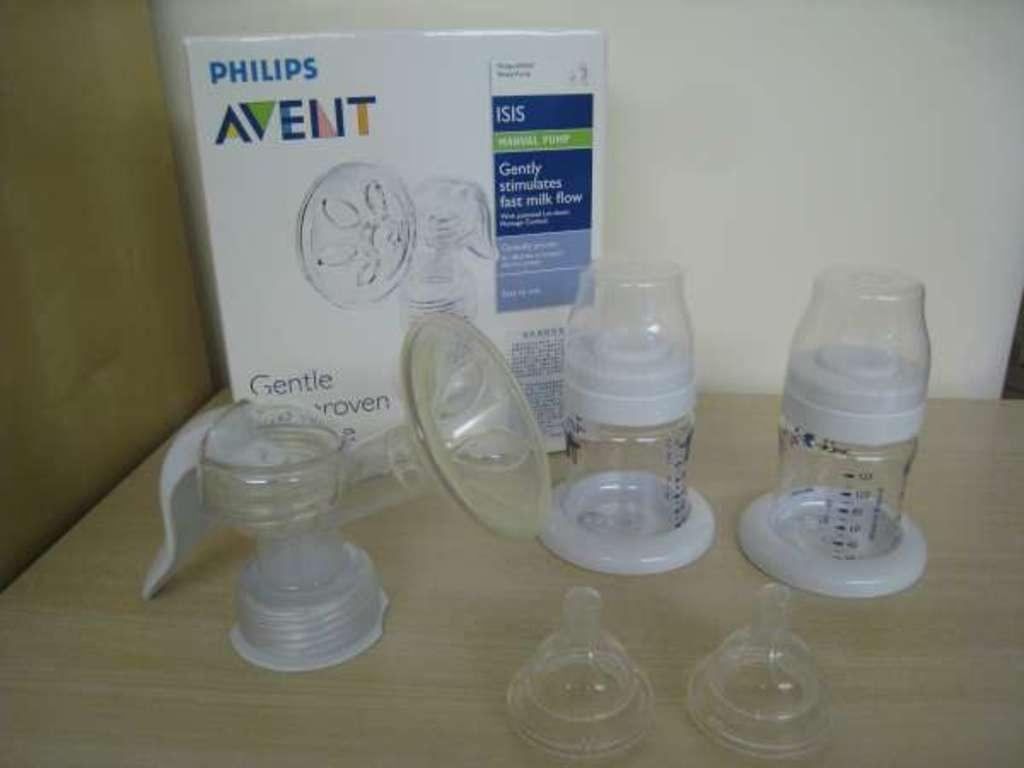How many plastic bottles are on the table in the image? There are 2 plastic bottles on the table. What else is present on the table besides the plastic bottles? There are sippers and a box on the table. What is written on the box? The box has "Philips Avent" written on it. How many dimes are scattered on the table in the image? There are no dimes present in the image. Is there a goose visible in the wilderness behind the table in the image? There is no wilderness or goose present in the image; it only shows a table with plastic bottles, sippers, and a box. 